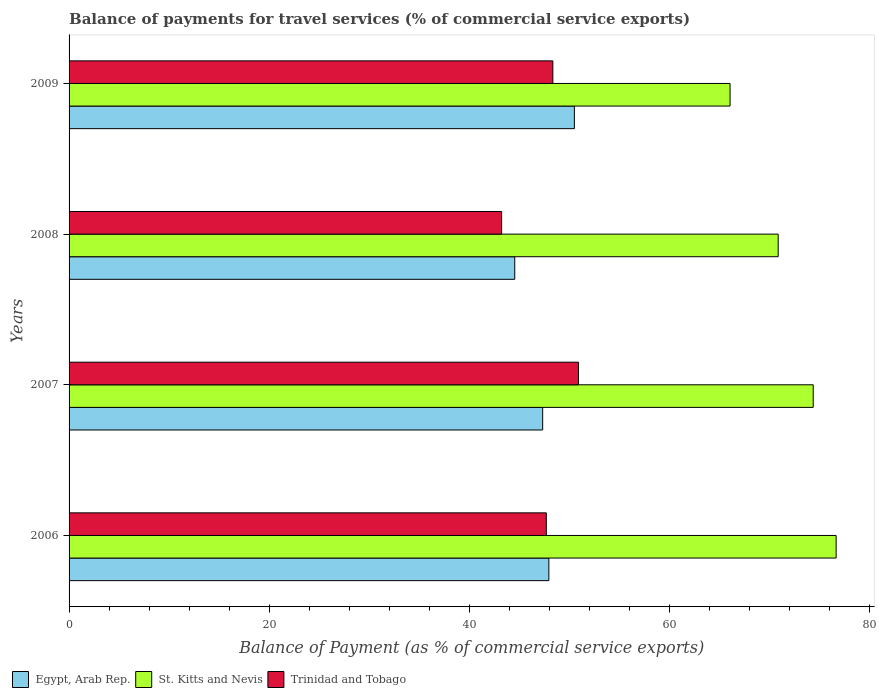How many groups of bars are there?
Keep it short and to the point. 4. Are the number of bars on each tick of the Y-axis equal?
Provide a short and direct response. Yes. How many bars are there on the 2nd tick from the bottom?
Give a very brief answer. 3. What is the label of the 1st group of bars from the top?
Ensure brevity in your answer.  2009. In how many cases, is the number of bars for a given year not equal to the number of legend labels?
Your answer should be compact. 0. What is the balance of payments for travel services in Trinidad and Tobago in 2008?
Offer a terse response. 43.22. Across all years, what is the maximum balance of payments for travel services in St. Kitts and Nevis?
Provide a succinct answer. 76.64. Across all years, what is the minimum balance of payments for travel services in Trinidad and Tobago?
Give a very brief answer. 43.22. In which year was the balance of payments for travel services in St. Kitts and Nevis minimum?
Provide a short and direct response. 2009. What is the total balance of payments for travel services in St. Kitts and Nevis in the graph?
Provide a short and direct response. 287.9. What is the difference between the balance of payments for travel services in Egypt, Arab Rep. in 2006 and that in 2009?
Provide a succinct answer. -2.55. What is the difference between the balance of payments for travel services in Egypt, Arab Rep. in 2006 and the balance of payments for travel services in Trinidad and Tobago in 2007?
Keep it short and to the point. -2.95. What is the average balance of payments for travel services in Trinidad and Tobago per year?
Offer a terse response. 47.54. In the year 2008, what is the difference between the balance of payments for travel services in St. Kitts and Nevis and balance of payments for travel services in Egypt, Arab Rep.?
Offer a very short reply. 26.32. What is the ratio of the balance of payments for travel services in St. Kitts and Nevis in 2008 to that in 2009?
Your answer should be very brief. 1.07. What is the difference between the highest and the second highest balance of payments for travel services in St. Kitts and Nevis?
Give a very brief answer. 2.29. What is the difference between the highest and the lowest balance of payments for travel services in St. Kitts and Nevis?
Your response must be concise. 10.6. Is the sum of the balance of payments for travel services in Egypt, Arab Rep. in 2006 and 2009 greater than the maximum balance of payments for travel services in Trinidad and Tobago across all years?
Offer a terse response. Yes. What does the 2nd bar from the top in 2009 represents?
Your answer should be very brief. St. Kitts and Nevis. What does the 3rd bar from the bottom in 2007 represents?
Provide a short and direct response. Trinidad and Tobago. How many bars are there?
Offer a terse response. 12. Are all the bars in the graph horizontal?
Provide a succinct answer. Yes. How many years are there in the graph?
Make the answer very short. 4. Are the values on the major ticks of X-axis written in scientific E-notation?
Provide a succinct answer. No. Where does the legend appear in the graph?
Provide a succinct answer. Bottom left. How many legend labels are there?
Keep it short and to the point. 3. How are the legend labels stacked?
Give a very brief answer. Horizontal. What is the title of the graph?
Your answer should be compact. Balance of payments for travel services (% of commercial service exports). Does "Upper middle income" appear as one of the legend labels in the graph?
Your answer should be compact. No. What is the label or title of the X-axis?
Your answer should be very brief. Balance of Payment (as % of commercial service exports). What is the label or title of the Y-axis?
Offer a very short reply. Years. What is the Balance of Payment (as % of commercial service exports) in Egypt, Arab Rep. in 2006?
Give a very brief answer. 47.94. What is the Balance of Payment (as % of commercial service exports) in St. Kitts and Nevis in 2006?
Provide a short and direct response. 76.64. What is the Balance of Payment (as % of commercial service exports) in Trinidad and Tobago in 2006?
Your answer should be very brief. 47.69. What is the Balance of Payment (as % of commercial service exports) of Egypt, Arab Rep. in 2007?
Give a very brief answer. 47.32. What is the Balance of Payment (as % of commercial service exports) of St. Kitts and Nevis in 2007?
Offer a terse response. 74.35. What is the Balance of Payment (as % of commercial service exports) of Trinidad and Tobago in 2007?
Keep it short and to the point. 50.9. What is the Balance of Payment (as % of commercial service exports) in Egypt, Arab Rep. in 2008?
Provide a short and direct response. 44.53. What is the Balance of Payment (as % of commercial service exports) of St. Kitts and Nevis in 2008?
Your response must be concise. 70.86. What is the Balance of Payment (as % of commercial service exports) in Trinidad and Tobago in 2008?
Provide a short and direct response. 43.22. What is the Balance of Payment (as % of commercial service exports) of Egypt, Arab Rep. in 2009?
Provide a short and direct response. 50.49. What is the Balance of Payment (as % of commercial service exports) of St. Kitts and Nevis in 2009?
Your response must be concise. 66.05. What is the Balance of Payment (as % of commercial service exports) in Trinidad and Tobago in 2009?
Provide a succinct answer. 48.34. Across all years, what is the maximum Balance of Payment (as % of commercial service exports) of Egypt, Arab Rep.?
Offer a terse response. 50.49. Across all years, what is the maximum Balance of Payment (as % of commercial service exports) of St. Kitts and Nevis?
Provide a short and direct response. 76.64. Across all years, what is the maximum Balance of Payment (as % of commercial service exports) of Trinidad and Tobago?
Provide a short and direct response. 50.9. Across all years, what is the minimum Balance of Payment (as % of commercial service exports) of Egypt, Arab Rep.?
Keep it short and to the point. 44.53. Across all years, what is the minimum Balance of Payment (as % of commercial service exports) of St. Kitts and Nevis?
Provide a short and direct response. 66.05. Across all years, what is the minimum Balance of Payment (as % of commercial service exports) of Trinidad and Tobago?
Offer a terse response. 43.22. What is the total Balance of Payment (as % of commercial service exports) of Egypt, Arab Rep. in the graph?
Offer a very short reply. 190.28. What is the total Balance of Payment (as % of commercial service exports) in St. Kitts and Nevis in the graph?
Your answer should be very brief. 287.9. What is the total Balance of Payment (as % of commercial service exports) in Trinidad and Tobago in the graph?
Provide a succinct answer. 190.14. What is the difference between the Balance of Payment (as % of commercial service exports) of Egypt, Arab Rep. in 2006 and that in 2007?
Keep it short and to the point. 0.62. What is the difference between the Balance of Payment (as % of commercial service exports) of St. Kitts and Nevis in 2006 and that in 2007?
Keep it short and to the point. 2.29. What is the difference between the Balance of Payment (as % of commercial service exports) in Trinidad and Tobago in 2006 and that in 2007?
Provide a succinct answer. -3.21. What is the difference between the Balance of Payment (as % of commercial service exports) in Egypt, Arab Rep. in 2006 and that in 2008?
Ensure brevity in your answer.  3.41. What is the difference between the Balance of Payment (as % of commercial service exports) in St. Kitts and Nevis in 2006 and that in 2008?
Offer a terse response. 5.79. What is the difference between the Balance of Payment (as % of commercial service exports) in Trinidad and Tobago in 2006 and that in 2008?
Ensure brevity in your answer.  4.46. What is the difference between the Balance of Payment (as % of commercial service exports) in Egypt, Arab Rep. in 2006 and that in 2009?
Offer a terse response. -2.55. What is the difference between the Balance of Payment (as % of commercial service exports) of St. Kitts and Nevis in 2006 and that in 2009?
Provide a short and direct response. 10.6. What is the difference between the Balance of Payment (as % of commercial service exports) of Trinidad and Tobago in 2006 and that in 2009?
Ensure brevity in your answer.  -0.65. What is the difference between the Balance of Payment (as % of commercial service exports) in Egypt, Arab Rep. in 2007 and that in 2008?
Give a very brief answer. 2.79. What is the difference between the Balance of Payment (as % of commercial service exports) of St. Kitts and Nevis in 2007 and that in 2008?
Provide a succinct answer. 3.5. What is the difference between the Balance of Payment (as % of commercial service exports) in Trinidad and Tobago in 2007 and that in 2008?
Your answer should be very brief. 7.67. What is the difference between the Balance of Payment (as % of commercial service exports) of Egypt, Arab Rep. in 2007 and that in 2009?
Keep it short and to the point. -3.17. What is the difference between the Balance of Payment (as % of commercial service exports) of St. Kitts and Nevis in 2007 and that in 2009?
Ensure brevity in your answer.  8.31. What is the difference between the Balance of Payment (as % of commercial service exports) of Trinidad and Tobago in 2007 and that in 2009?
Your answer should be compact. 2.56. What is the difference between the Balance of Payment (as % of commercial service exports) of Egypt, Arab Rep. in 2008 and that in 2009?
Your answer should be very brief. -5.96. What is the difference between the Balance of Payment (as % of commercial service exports) of St. Kitts and Nevis in 2008 and that in 2009?
Your answer should be very brief. 4.81. What is the difference between the Balance of Payment (as % of commercial service exports) of Trinidad and Tobago in 2008 and that in 2009?
Provide a succinct answer. -5.12. What is the difference between the Balance of Payment (as % of commercial service exports) of Egypt, Arab Rep. in 2006 and the Balance of Payment (as % of commercial service exports) of St. Kitts and Nevis in 2007?
Your response must be concise. -26.41. What is the difference between the Balance of Payment (as % of commercial service exports) of Egypt, Arab Rep. in 2006 and the Balance of Payment (as % of commercial service exports) of Trinidad and Tobago in 2007?
Keep it short and to the point. -2.95. What is the difference between the Balance of Payment (as % of commercial service exports) in St. Kitts and Nevis in 2006 and the Balance of Payment (as % of commercial service exports) in Trinidad and Tobago in 2007?
Your response must be concise. 25.75. What is the difference between the Balance of Payment (as % of commercial service exports) of Egypt, Arab Rep. in 2006 and the Balance of Payment (as % of commercial service exports) of St. Kitts and Nevis in 2008?
Offer a terse response. -22.91. What is the difference between the Balance of Payment (as % of commercial service exports) of Egypt, Arab Rep. in 2006 and the Balance of Payment (as % of commercial service exports) of Trinidad and Tobago in 2008?
Your answer should be very brief. 4.72. What is the difference between the Balance of Payment (as % of commercial service exports) of St. Kitts and Nevis in 2006 and the Balance of Payment (as % of commercial service exports) of Trinidad and Tobago in 2008?
Your answer should be very brief. 33.42. What is the difference between the Balance of Payment (as % of commercial service exports) of Egypt, Arab Rep. in 2006 and the Balance of Payment (as % of commercial service exports) of St. Kitts and Nevis in 2009?
Your answer should be very brief. -18.1. What is the difference between the Balance of Payment (as % of commercial service exports) of Egypt, Arab Rep. in 2006 and the Balance of Payment (as % of commercial service exports) of Trinidad and Tobago in 2009?
Offer a very short reply. -0.4. What is the difference between the Balance of Payment (as % of commercial service exports) in St. Kitts and Nevis in 2006 and the Balance of Payment (as % of commercial service exports) in Trinidad and Tobago in 2009?
Keep it short and to the point. 28.31. What is the difference between the Balance of Payment (as % of commercial service exports) in Egypt, Arab Rep. in 2007 and the Balance of Payment (as % of commercial service exports) in St. Kitts and Nevis in 2008?
Give a very brief answer. -23.53. What is the difference between the Balance of Payment (as % of commercial service exports) of Egypt, Arab Rep. in 2007 and the Balance of Payment (as % of commercial service exports) of Trinidad and Tobago in 2008?
Ensure brevity in your answer.  4.1. What is the difference between the Balance of Payment (as % of commercial service exports) in St. Kitts and Nevis in 2007 and the Balance of Payment (as % of commercial service exports) in Trinidad and Tobago in 2008?
Offer a terse response. 31.13. What is the difference between the Balance of Payment (as % of commercial service exports) of Egypt, Arab Rep. in 2007 and the Balance of Payment (as % of commercial service exports) of St. Kitts and Nevis in 2009?
Offer a very short reply. -18.72. What is the difference between the Balance of Payment (as % of commercial service exports) in Egypt, Arab Rep. in 2007 and the Balance of Payment (as % of commercial service exports) in Trinidad and Tobago in 2009?
Your response must be concise. -1.02. What is the difference between the Balance of Payment (as % of commercial service exports) of St. Kitts and Nevis in 2007 and the Balance of Payment (as % of commercial service exports) of Trinidad and Tobago in 2009?
Your answer should be very brief. 26.02. What is the difference between the Balance of Payment (as % of commercial service exports) of Egypt, Arab Rep. in 2008 and the Balance of Payment (as % of commercial service exports) of St. Kitts and Nevis in 2009?
Your answer should be compact. -21.51. What is the difference between the Balance of Payment (as % of commercial service exports) of Egypt, Arab Rep. in 2008 and the Balance of Payment (as % of commercial service exports) of Trinidad and Tobago in 2009?
Your answer should be compact. -3.81. What is the difference between the Balance of Payment (as % of commercial service exports) of St. Kitts and Nevis in 2008 and the Balance of Payment (as % of commercial service exports) of Trinidad and Tobago in 2009?
Give a very brief answer. 22.52. What is the average Balance of Payment (as % of commercial service exports) in Egypt, Arab Rep. per year?
Provide a short and direct response. 47.57. What is the average Balance of Payment (as % of commercial service exports) of St. Kitts and Nevis per year?
Your answer should be very brief. 71.98. What is the average Balance of Payment (as % of commercial service exports) in Trinidad and Tobago per year?
Provide a succinct answer. 47.54. In the year 2006, what is the difference between the Balance of Payment (as % of commercial service exports) in Egypt, Arab Rep. and Balance of Payment (as % of commercial service exports) in St. Kitts and Nevis?
Keep it short and to the point. -28.7. In the year 2006, what is the difference between the Balance of Payment (as % of commercial service exports) in Egypt, Arab Rep. and Balance of Payment (as % of commercial service exports) in Trinidad and Tobago?
Provide a short and direct response. 0.26. In the year 2006, what is the difference between the Balance of Payment (as % of commercial service exports) in St. Kitts and Nevis and Balance of Payment (as % of commercial service exports) in Trinidad and Tobago?
Offer a terse response. 28.96. In the year 2007, what is the difference between the Balance of Payment (as % of commercial service exports) of Egypt, Arab Rep. and Balance of Payment (as % of commercial service exports) of St. Kitts and Nevis?
Your answer should be very brief. -27.03. In the year 2007, what is the difference between the Balance of Payment (as % of commercial service exports) in Egypt, Arab Rep. and Balance of Payment (as % of commercial service exports) in Trinidad and Tobago?
Offer a very short reply. -3.57. In the year 2007, what is the difference between the Balance of Payment (as % of commercial service exports) of St. Kitts and Nevis and Balance of Payment (as % of commercial service exports) of Trinidad and Tobago?
Ensure brevity in your answer.  23.46. In the year 2008, what is the difference between the Balance of Payment (as % of commercial service exports) of Egypt, Arab Rep. and Balance of Payment (as % of commercial service exports) of St. Kitts and Nevis?
Make the answer very short. -26.32. In the year 2008, what is the difference between the Balance of Payment (as % of commercial service exports) in Egypt, Arab Rep. and Balance of Payment (as % of commercial service exports) in Trinidad and Tobago?
Your answer should be compact. 1.31. In the year 2008, what is the difference between the Balance of Payment (as % of commercial service exports) of St. Kitts and Nevis and Balance of Payment (as % of commercial service exports) of Trinidad and Tobago?
Your answer should be very brief. 27.63. In the year 2009, what is the difference between the Balance of Payment (as % of commercial service exports) in Egypt, Arab Rep. and Balance of Payment (as % of commercial service exports) in St. Kitts and Nevis?
Make the answer very short. -15.56. In the year 2009, what is the difference between the Balance of Payment (as % of commercial service exports) in Egypt, Arab Rep. and Balance of Payment (as % of commercial service exports) in Trinidad and Tobago?
Keep it short and to the point. 2.15. In the year 2009, what is the difference between the Balance of Payment (as % of commercial service exports) in St. Kitts and Nevis and Balance of Payment (as % of commercial service exports) in Trinidad and Tobago?
Offer a very short reply. 17.71. What is the ratio of the Balance of Payment (as % of commercial service exports) of Egypt, Arab Rep. in 2006 to that in 2007?
Offer a terse response. 1.01. What is the ratio of the Balance of Payment (as % of commercial service exports) in St. Kitts and Nevis in 2006 to that in 2007?
Your response must be concise. 1.03. What is the ratio of the Balance of Payment (as % of commercial service exports) of Trinidad and Tobago in 2006 to that in 2007?
Provide a succinct answer. 0.94. What is the ratio of the Balance of Payment (as % of commercial service exports) in Egypt, Arab Rep. in 2006 to that in 2008?
Your answer should be compact. 1.08. What is the ratio of the Balance of Payment (as % of commercial service exports) in St. Kitts and Nevis in 2006 to that in 2008?
Your answer should be very brief. 1.08. What is the ratio of the Balance of Payment (as % of commercial service exports) of Trinidad and Tobago in 2006 to that in 2008?
Your answer should be compact. 1.1. What is the ratio of the Balance of Payment (as % of commercial service exports) in Egypt, Arab Rep. in 2006 to that in 2009?
Provide a short and direct response. 0.95. What is the ratio of the Balance of Payment (as % of commercial service exports) of St. Kitts and Nevis in 2006 to that in 2009?
Make the answer very short. 1.16. What is the ratio of the Balance of Payment (as % of commercial service exports) in Trinidad and Tobago in 2006 to that in 2009?
Your answer should be very brief. 0.99. What is the ratio of the Balance of Payment (as % of commercial service exports) in Egypt, Arab Rep. in 2007 to that in 2008?
Your answer should be compact. 1.06. What is the ratio of the Balance of Payment (as % of commercial service exports) in St. Kitts and Nevis in 2007 to that in 2008?
Give a very brief answer. 1.05. What is the ratio of the Balance of Payment (as % of commercial service exports) in Trinidad and Tobago in 2007 to that in 2008?
Your answer should be compact. 1.18. What is the ratio of the Balance of Payment (as % of commercial service exports) in Egypt, Arab Rep. in 2007 to that in 2009?
Provide a succinct answer. 0.94. What is the ratio of the Balance of Payment (as % of commercial service exports) in St. Kitts and Nevis in 2007 to that in 2009?
Your response must be concise. 1.13. What is the ratio of the Balance of Payment (as % of commercial service exports) in Trinidad and Tobago in 2007 to that in 2009?
Provide a short and direct response. 1.05. What is the ratio of the Balance of Payment (as % of commercial service exports) of Egypt, Arab Rep. in 2008 to that in 2009?
Provide a succinct answer. 0.88. What is the ratio of the Balance of Payment (as % of commercial service exports) in St. Kitts and Nevis in 2008 to that in 2009?
Ensure brevity in your answer.  1.07. What is the ratio of the Balance of Payment (as % of commercial service exports) of Trinidad and Tobago in 2008 to that in 2009?
Give a very brief answer. 0.89. What is the difference between the highest and the second highest Balance of Payment (as % of commercial service exports) of Egypt, Arab Rep.?
Offer a terse response. 2.55. What is the difference between the highest and the second highest Balance of Payment (as % of commercial service exports) in St. Kitts and Nevis?
Your answer should be very brief. 2.29. What is the difference between the highest and the second highest Balance of Payment (as % of commercial service exports) in Trinidad and Tobago?
Keep it short and to the point. 2.56. What is the difference between the highest and the lowest Balance of Payment (as % of commercial service exports) of Egypt, Arab Rep.?
Make the answer very short. 5.96. What is the difference between the highest and the lowest Balance of Payment (as % of commercial service exports) of St. Kitts and Nevis?
Give a very brief answer. 10.6. What is the difference between the highest and the lowest Balance of Payment (as % of commercial service exports) in Trinidad and Tobago?
Provide a short and direct response. 7.67. 